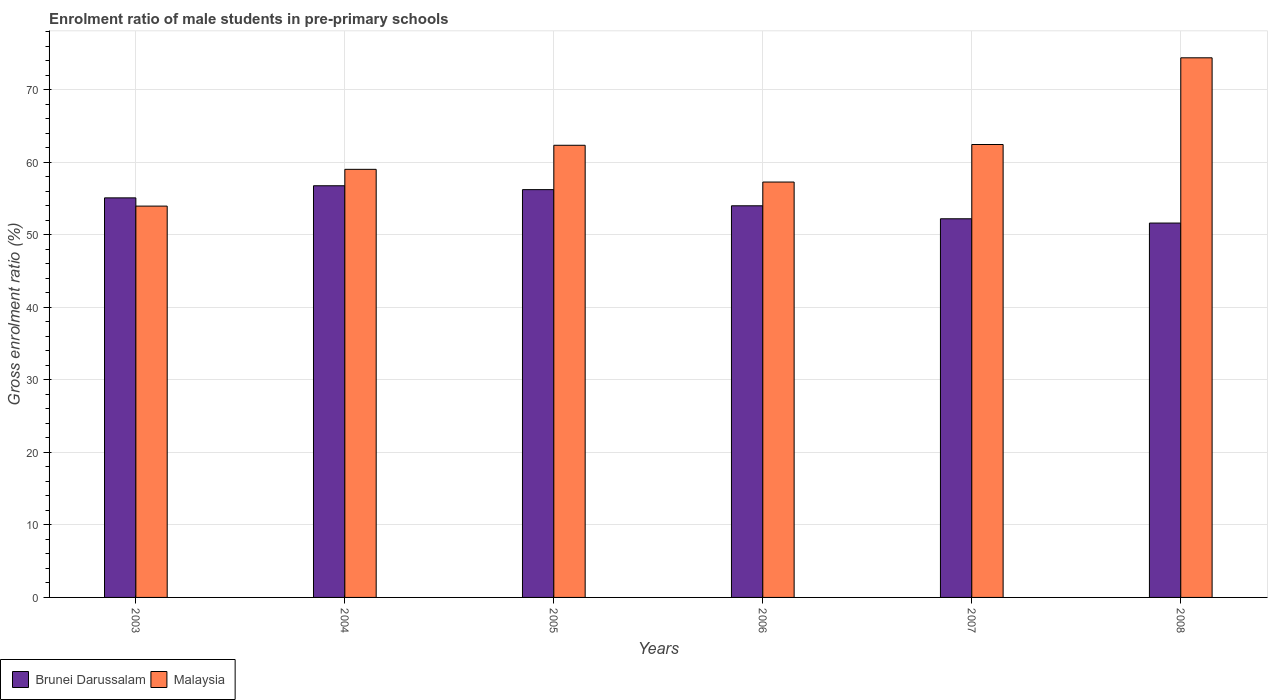How many different coloured bars are there?
Make the answer very short. 2. How many groups of bars are there?
Ensure brevity in your answer.  6. How many bars are there on the 5th tick from the left?
Ensure brevity in your answer.  2. What is the label of the 2nd group of bars from the left?
Give a very brief answer. 2004. In how many cases, is the number of bars for a given year not equal to the number of legend labels?
Give a very brief answer. 0. What is the enrolment ratio of male students in pre-primary schools in Brunei Darussalam in 2004?
Provide a short and direct response. 56.77. Across all years, what is the maximum enrolment ratio of male students in pre-primary schools in Brunei Darussalam?
Offer a terse response. 56.77. Across all years, what is the minimum enrolment ratio of male students in pre-primary schools in Malaysia?
Provide a succinct answer. 53.96. In which year was the enrolment ratio of male students in pre-primary schools in Malaysia maximum?
Provide a short and direct response. 2008. In which year was the enrolment ratio of male students in pre-primary schools in Brunei Darussalam minimum?
Give a very brief answer. 2008. What is the total enrolment ratio of male students in pre-primary schools in Brunei Darussalam in the graph?
Make the answer very short. 325.96. What is the difference between the enrolment ratio of male students in pre-primary schools in Brunei Darussalam in 2005 and that in 2008?
Your answer should be compact. 4.61. What is the difference between the enrolment ratio of male students in pre-primary schools in Malaysia in 2005 and the enrolment ratio of male students in pre-primary schools in Brunei Darussalam in 2004?
Provide a succinct answer. 5.58. What is the average enrolment ratio of male students in pre-primary schools in Brunei Darussalam per year?
Give a very brief answer. 54.33. In the year 2003, what is the difference between the enrolment ratio of male students in pre-primary schools in Malaysia and enrolment ratio of male students in pre-primary schools in Brunei Darussalam?
Your answer should be compact. -1.14. What is the ratio of the enrolment ratio of male students in pre-primary schools in Brunei Darussalam in 2007 to that in 2008?
Your response must be concise. 1.01. Is the enrolment ratio of male students in pre-primary schools in Malaysia in 2004 less than that in 2008?
Offer a very short reply. Yes. What is the difference between the highest and the second highest enrolment ratio of male students in pre-primary schools in Malaysia?
Your answer should be very brief. 11.96. What is the difference between the highest and the lowest enrolment ratio of male students in pre-primary schools in Malaysia?
Provide a succinct answer. 20.45. In how many years, is the enrolment ratio of male students in pre-primary schools in Brunei Darussalam greater than the average enrolment ratio of male students in pre-primary schools in Brunei Darussalam taken over all years?
Keep it short and to the point. 3. What does the 1st bar from the left in 2003 represents?
Give a very brief answer. Brunei Darussalam. What does the 1st bar from the right in 2003 represents?
Your response must be concise. Malaysia. Does the graph contain any zero values?
Make the answer very short. No. Does the graph contain grids?
Give a very brief answer. Yes. How many legend labels are there?
Your answer should be very brief. 2. How are the legend labels stacked?
Your answer should be very brief. Horizontal. What is the title of the graph?
Your answer should be compact. Enrolment ratio of male students in pre-primary schools. What is the Gross enrolment ratio (%) of Brunei Darussalam in 2003?
Your response must be concise. 55.1. What is the Gross enrolment ratio (%) of Malaysia in 2003?
Provide a succinct answer. 53.96. What is the Gross enrolment ratio (%) of Brunei Darussalam in 2004?
Keep it short and to the point. 56.77. What is the Gross enrolment ratio (%) in Malaysia in 2004?
Keep it short and to the point. 59.04. What is the Gross enrolment ratio (%) of Brunei Darussalam in 2005?
Keep it short and to the point. 56.24. What is the Gross enrolment ratio (%) of Malaysia in 2005?
Your answer should be very brief. 62.35. What is the Gross enrolment ratio (%) of Brunei Darussalam in 2006?
Offer a terse response. 54.01. What is the Gross enrolment ratio (%) of Malaysia in 2006?
Your answer should be compact. 57.28. What is the Gross enrolment ratio (%) of Brunei Darussalam in 2007?
Provide a succinct answer. 52.22. What is the Gross enrolment ratio (%) in Malaysia in 2007?
Provide a short and direct response. 62.46. What is the Gross enrolment ratio (%) of Brunei Darussalam in 2008?
Give a very brief answer. 51.63. What is the Gross enrolment ratio (%) of Malaysia in 2008?
Your response must be concise. 74.42. Across all years, what is the maximum Gross enrolment ratio (%) of Brunei Darussalam?
Give a very brief answer. 56.77. Across all years, what is the maximum Gross enrolment ratio (%) in Malaysia?
Offer a very short reply. 74.42. Across all years, what is the minimum Gross enrolment ratio (%) in Brunei Darussalam?
Offer a very short reply. 51.63. Across all years, what is the minimum Gross enrolment ratio (%) in Malaysia?
Offer a terse response. 53.96. What is the total Gross enrolment ratio (%) of Brunei Darussalam in the graph?
Your answer should be compact. 325.96. What is the total Gross enrolment ratio (%) in Malaysia in the graph?
Offer a terse response. 369.51. What is the difference between the Gross enrolment ratio (%) in Brunei Darussalam in 2003 and that in 2004?
Your answer should be very brief. -1.67. What is the difference between the Gross enrolment ratio (%) in Malaysia in 2003 and that in 2004?
Keep it short and to the point. -5.07. What is the difference between the Gross enrolment ratio (%) of Brunei Darussalam in 2003 and that in 2005?
Make the answer very short. -1.14. What is the difference between the Gross enrolment ratio (%) in Malaysia in 2003 and that in 2005?
Give a very brief answer. -8.39. What is the difference between the Gross enrolment ratio (%) of Brunei Darussalam in 2003 and that in 2006?
Keep it short and to the point. 1.09. What is the difference between the Gross enrolment ratio (%) in Malaysia in 2003 and that in 2006?
Make the answer very short. -3.32. What is the difference between the Gross enrolment ratio (%) of Brunei Darussalam in 2003 and that in 2007?
Offer a terse response. 2.88. What is the difference between the Gross enrolment ratio (%) in Malaysia in 2003 and that in 2007?
Offer a terse response. -8.5. What is the difference between the Gross enrolment ratio (%) of Brunei Darussalam in 2003 and that in 2008?
Your answer should be compact. 3.47. What is the difference between the Gross enrolment ratio (%) in Malaysia in 2003 and that in 2008?
Provide a succinct answer. -20.45. What is the difference between the Gross enrolment ratio (%) of Brunei Darussalam in 2004 and that in 2005?
Provide a short and direct response. 0.53. What is the difference between the Gross enrolment ratio (%) in Malaysia in 2004 and that in 2005?
Offer a terse response. -3.32. What is the difference between the Gross enrolment ratio (%) of Brunei Darussalam in 2004 and that in 2006?
Keep it short and to the point. 2.76. What is the difference between the Gross enrolment ratio (%) in Malaysia in 2004 and that in 2006?
Your answer should be compact. 1.75. What is the difference between the Gross enrolment ratio (%) of Brunei Darussalam in 2004 and that in 2007?
Your answer should be compact. 4.55. What is the difference between the Gross enrolment ratio (%) of Malaysia in 2004 and that in 2007?
Ensure brevity in your answer.  -3.42. What is the difference between the Gross enrolment ratio (%) of Brunei Darussalam in 2004 and that in 2008?
Your answer should be compact. 5.14. What is the difference between the Gross enrolment ratio (%) of Malaysia in 2004 and that in 2008?
Offer a terse response. -15.38. What is the difference between the Gross enrolment ratio (%) in Brunei Darussalam in 2005 and that in 2006?
Provide a succinct answer. 2.23. What is the difference between the Gross enrolment ratio (%) in Malaysia in 2005 and that in 2006?
Offer a terse response. 5.07. What is the difference between the Gross enrolment ratio (%) of Brunei Darussalam in 2005 and that in 2007?
Your answer should be compact. 4.02. What is the difference between the Gross enrolment ratio (%) of Malaysia in 2005 and that in 2007?
Provide a short and direct response. -0.11. What is the difference between the Gross enrolment ratio (%) in Brunei Darussalam in 2005 and that in 2008?
Offer a terse response. 4.61. What is the difference between the Gross enrolment ratio (%) in Malaysia in 2005 and that in 2008?
Keep it short and to the point. -12.06. What is the difference between the Gross enrolment ratio (%) of Brunei Darussalam in 2006 and that in 2007?
Your response must be concise. 1.79. What is the difference between the Gross enrolment ratio (%) of Malaysia in 2006 and that in 2007?
Your response must be concise. -5.18. What is the difference between the Gross enrolment ratio (%) of Brunei Darussalam in 2006 and that in 2008?
Offer a very short reply. 2.38. What is the difference between the Gross enrolment ratio (%) of Malaysia in 2006 and that in 2008?
Keep it short and to the point. -17.13. What is the difference between the Gross enrolment ratio (%) in Brunei Darussalam in 2007 and that in 2008?
Give a very brief answer. 0.59. What is the difference between the Gross enrolment ratio (%) of Malaysia in 2007 and that in 2008?
Offer a very short reply. -11.96. What is the difference between the Gross enrolment ratio (%) in Brunei Darussalam in 2003 and the Gross enrolment ratio (%) in Malaysia in 2004?
Your answer should be very brief. -3.94. What is the difference between the Gross enrolment ratio (%) of Brunei Darussalam in 2003 and the Gross enrolment ratio (%) of Malaysia in 2005?
Ensure brevity in your answer.  -7.25. What is the difference between the Gross enrolment ratio (%) in Brunei Darussalam in 2003 and the Gross enrolment ratio (%) in Malaysia in 2006?
Your response must be concise. -2.18. What is the difference between the Gross enrolment ratio (%) in Brunei Darussalam in 2003 and the Gross enrolment ratio (%) in Malaysia in 2007?
Offer a terse response. -7.36. What is the difference between the Gross enrolment ratio (%) in Brunei Darussalam in 2003 and the Gross enrolment ratio (%) in Malaysia in 2008?
Provide a short and direct response. -19.32. What is the difference between the Gross enrolment ratio (%) in Brunei Darussalam in 2004 and the Gross enrolment ratio (%) in Malaysia in 2005?
Your answer should be very brief. -5.58. What is the difference between the Gross enrolment ratio (%) of Brunei Darussalam in 2004 and the Gross enrolment ratio (%) of Malaysia in 2006?
Your response must be concise. -0.51. What is the difference between the Gross enrolment ratio (%) of Brunei Darussalam in 2004 and the Gross enrolment ratio (%) of Malaysia in 2007?
Offer a very short reply. -5.69. What is the difference between the Gross enrolment ratio (%) in Brunei Darussalam in 2004 and the Gross enrolment ratio (%) in Malaysia in 2008?
Provide a succinct answer. -17.65. What is the difference between the Gross enrolment ratio (%) in Brunei Darussalam in 2005 and the Gross enrolment ratio (%) in Malaysia in 2006?
Your answer should be very brief. -1.05. What is the difference between the Gross enrolment ratio (%) of Brunei Darussalam in 2005 and the Gross enrolment ratio (%) of Malaysia in 2007?
Provide a succinct answer. -6.22. What is the difference between the Gross enrolment ratio (%) of Brunei Darussalam in 2005 and the Gross enrolment ratio (%) of Malaysia in 2008?
Provide a succinct answer. -18.18. What is the difference between the Gross enrolment ratio (%) in Brunei Darussalam in 2006 and the Gross enrolment ratio (%) in Malaysia in 2007?
Give a very brief answer. -8.45. What is the difference between the Gross enrolment ratio (%) in Brunei Darussalam in 2006 and the Gross enrolment ratio (%) in Malaysia in 2008?
Your response must be concise. -20.41. What is the difference between the Gross enrolment ratio (%) in Brunei Darussalam in 2007 and the Gross enrolment ratio (%) in Malaysia in 2008?
Your answer should be compact. -22.2. What is the average Gross enrolment ratio (%) in Brunei Darussalam per year?
Your response must be concise. 54.33. What is the average Gross enrolment ratio (%) of Malaysia per year?
Provide a succinct answer. 61.59. In the year 2003, what is the difference between the Gross enrolment ratio (%) of Brunei Darussalam and Gross enrolment ratio (%) of Malaysia?
Your answer should be compact. 1.14. In the year 2004, what is the difference between the Gross enrolment ratio (%) in Brunei Darussalam and Gross enrolment ratio (%) in Malaysia?
Your answer should be compact. -2.27. In the year 2005, what is the difference between the Gross enrolment ratio (%) in Brunei Darussalam and Gross enrolment ratio (%) in Malaysia?
Your answer should be compact. -6.12. In the year 2006, what is the difference between the Gross enrolment ratio (%) in Brunei Darussalam and Gross enrolment ratio (%) in Malaysia?
Give a very brief answer. -3.28. In the year 2007, what is the difference between the Gross enrolment ratio (%) of Brunei Darussalam and Gross enrolment ratio (%) of Malaysia?
Your response must be concise. -10.24. In the year 2008, what is the difference between the Gross enrolment ratio (%) of Brunei Darussalam and Gross enrolment ratio (%) of Malaysia?
Ensure brevity in your answer.  -22.79. What is the ratio of the Gross enrolment ratio (%) of Brunei Darussalam in 2003 to that in 2004?
Ensure brevity in your answer.  0.97. What is the ratio of the Gross enrolment ratio (%) of Malaysia in 2003 to that in 2004?
Make the answer very short. 0.91. What is the ratio of the Gross enrolment ratio (%) in Brunei Darussalam in 2003 to that in 2005?
Make the answer very short. 0.98. What is the ratio of the Gross enrolment ratio (%) of Malaysia in 2003 to that in 2005?
Make the answer very short. 0.87. What is the ratio of the Gross enrolment ratio (%) of Brunei Darussalam in 2003 to that in 2006?
Your response must be concise. 1.02. What is the ratio of the Gross enrolment ratio (%) in Malaysia in 2003 to that in 2006?
Ensure brevity in your answer.  0.94. What is the ratio of the Gross enrolment ratio (%) in Brunei Darussalam in 2003 to that in 2007?
Offer a very short reply. 1.06. What is the ratio of the Gross enrolment ratio (%) in Malaysia in 2003 to that in 2007?
Provide a succinct answer. 0.86. What is the ratio of the Gross enrolment ratio (%) of Brunei Darussalam in 2003 to that in 2008?
Ensure brevity in your answer.  1.07. What is the ratio of the Gross enrolment ratio (%) of Malaysia in 2003 to that in 2008?
Provide a short and direct response. 0.73. What is the ratio of the Gross enrolment ratio (%) of Brunei Darussalam in 2004 to that in 2005?
Keep it short and to the point. 1.01. What is the ratio of the Gross enrolment ratio (%) of Malaysia in 2004 to that in 2005?
Your response must be concise. 0.95. What is the ratio of the Gross enrolment ratio (%) of Brunei Darussalam in 2004 to that in 2006?
Ensure brevity in your answer.  1.05. What is the ratio of the Gross enrolment ratio (%) of Malaysia in 2004 to that in 2006?
Ensure brevity in your answer.  1.03. What is the ratio of the Gross enrolment ratio (%) of Brunei Darussalam in 2004 to that in 2007?
Provide a short and direct response. 1.09. What is the ratio of the Gross enrolment ratio (%) of Malaysia in 2004 to that in 2007?
Give a very brief answer. 0.95. What is the ratio of the Gross enrolment ratio (%) of Brunei Darussalam in 2004 to that in 2008?
Keep it short and to the point. 1.1. What is the ratio of the Gross enrolment ratio (%) of Malaysia in 2004 to that in 2008?
Your answer should be very brief. 0.79. What is the ratio of the Gross enrolment ratio (%) in Brunei Darussalam in 2005 to that in 2006?
Your answer should be compact. 1.04. What is the ratio of the Gross enrolment ratio (%) in Malaysia in 2005 to that in 2006?
Ensure brevity in your answer.  1.09. What is the ratio of the Gross enrolment ratio (%) in Brunei Darussalam in 2005 to that in 2007?
Your response must be concise. 1.08. What is the ratio of the Gross enrolment ratio (%) in Brunei Darussalam in 2005 to that in 2008?
Your answer should be compact. 1.09. What is the ratio of the Gross enrolment ratio (%) of Malaysia in 2005 to that in 2008?
Keep it short and to the point. 0.84. What is the ratio of the Gross enrolment ratio (%) in Brunei Darussalam in 2006 to that in 2007?
Ensure brevity in your answer.  1.03. What is the ratio of the Gross enrolment ratio (%) of Malaysia in 2006 to that in 2007?
Provide a succinct answer. 0.92. What is the ratio of the Gross enrolment ratio (%) in Brunei Darussalam in 2006 to that in 2008?
Keep it short and to the point. 1.05. What is the ratio of the Gross enrolment ratio (%) in Malaysia in 2006 to that in 2008?
Your answer should be very brief. 0.77. What is the ratio of the Gross enrolment ratio (%) of Brunei Darussalam in 2007 to that in 2008?
Make the answer very short. 1.01. What is the ratio of the Gross enrolment ratio (%) in Malaysia in 2007 to that in 2008?
Make the answer very short. 0.84. What is the difference between the highest and the second highest Gross enrolment ratio (%) in Brunei Darussalam?
Your answer should be compact. 0.53. What is the difference between the highest and the second highest Gross enrolment ratio (%) in Malaysia?
Your response must be concise. 11.96. What is the difference between the highest and the lowest Gross enrolment ratio (%) of Brunei Darussalam?
Ensure brevity in your answer.  5.14. What is the difference between the highest and the lowest Gross enrolment ratio (%) of Malaysia?
Your response must be concise. 20.45. 